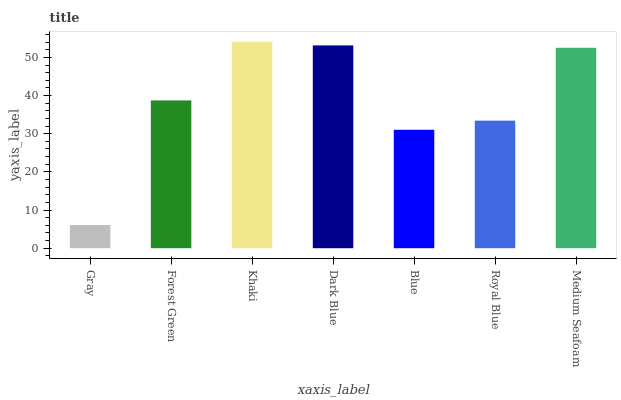Is Gray the minimum?
Answer yes or no. Yes. Is Khaki the maximum?
Answer yes or no. Yes. Is Forest Green the minimum?
Answer yes or no. No. Is Forest Green the maximum?
Answer yes or no. No. Is Forest Green greater than Gray?
Answer yes or no. Yes. Is Gray less than Forest Green?
Answer yes or no. Yes. Is Gray greater than Forest Green?
Answer yes or no. No. Is Forest Green less than Gray?
Answer yes or no. No. Is Forest Green the high median?
Answer yes or no. Yes. Is Forest Green the low median?
Answer yes or no. Yes. Is Gray the high median?
Answer yes or no. No. Is Medium Seafoam the low median?
Answer yes or no. No. 